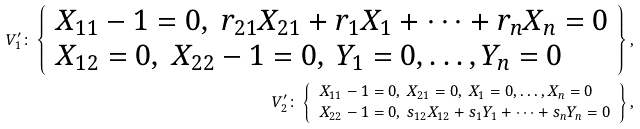<formula> <loc_0><loc_0><loc_500><loc_500>V _ { 1 } ^ { \prime } \colon \left \{ \begin{array} { l } X _ { 1 1 } - 1 = 0 , \ r _ { 2 1 } X _ { 2 1 } + r _ { 1 } X _ { 1 } + \cdots + r _ { n } X _ { n } = 0 \\ X _ { 1 2 } = 0 , \ X _ { 2 2 } - 1 = 0 , \ Y _ { 1 } = 0 , \dots , Y _ { n } = 0 \end{array} \right \} , \\ V _ { 2 } ^ { \prime } \colon \left \{ \begin{array} { l } X _ { 1 1 } - 1 = 0 , \ X _ { 2 1 } = 0 , \ X _ { 1 } = 0 , \dots , X _ { n } = 0 \\ X _ { 2 2 } - 1 = 0 , \ s _ { 1 2 } X _ { 1 2 } + s _ { 1 } Y _ { 1 } + \dots + s _ { n } Y _ { n } = 0 \end{array} \right \} ,</formula> 